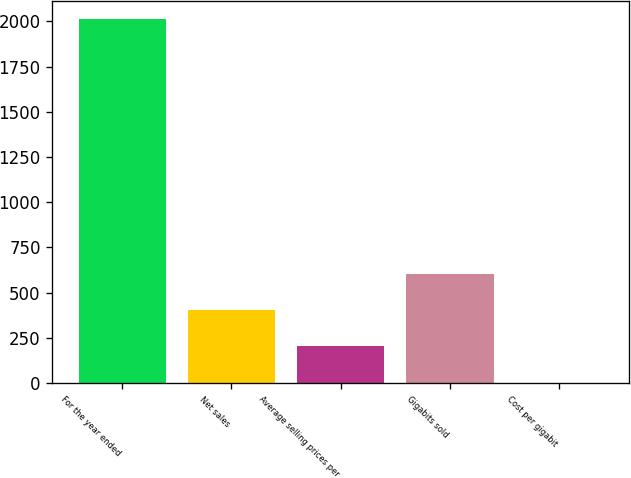<chart> <loc_0><loc_0><loc_500><loc_500><bar_chart><fcel>For the year ended<fcel>Net sales<fcel>Average selling prices per<fcel>Gigabits sold<fcel>Cost per gigabit<nl><fcel>2011<fcel>403.8<fcel>202.9<fcel>604.7<fcel>2<nl></chart> 